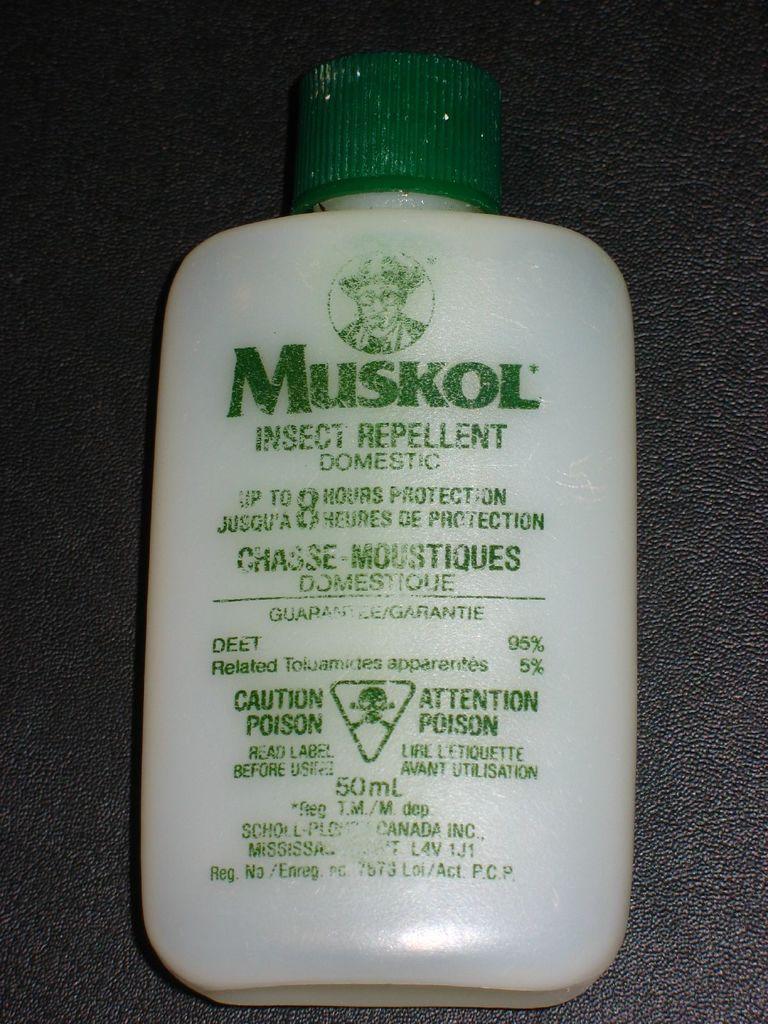How many hours of protection does the repellent provide?
Ensure brevity in your answer.  8. What brand of insect repellent is this?
Your answer should be very brief. Muskol. 